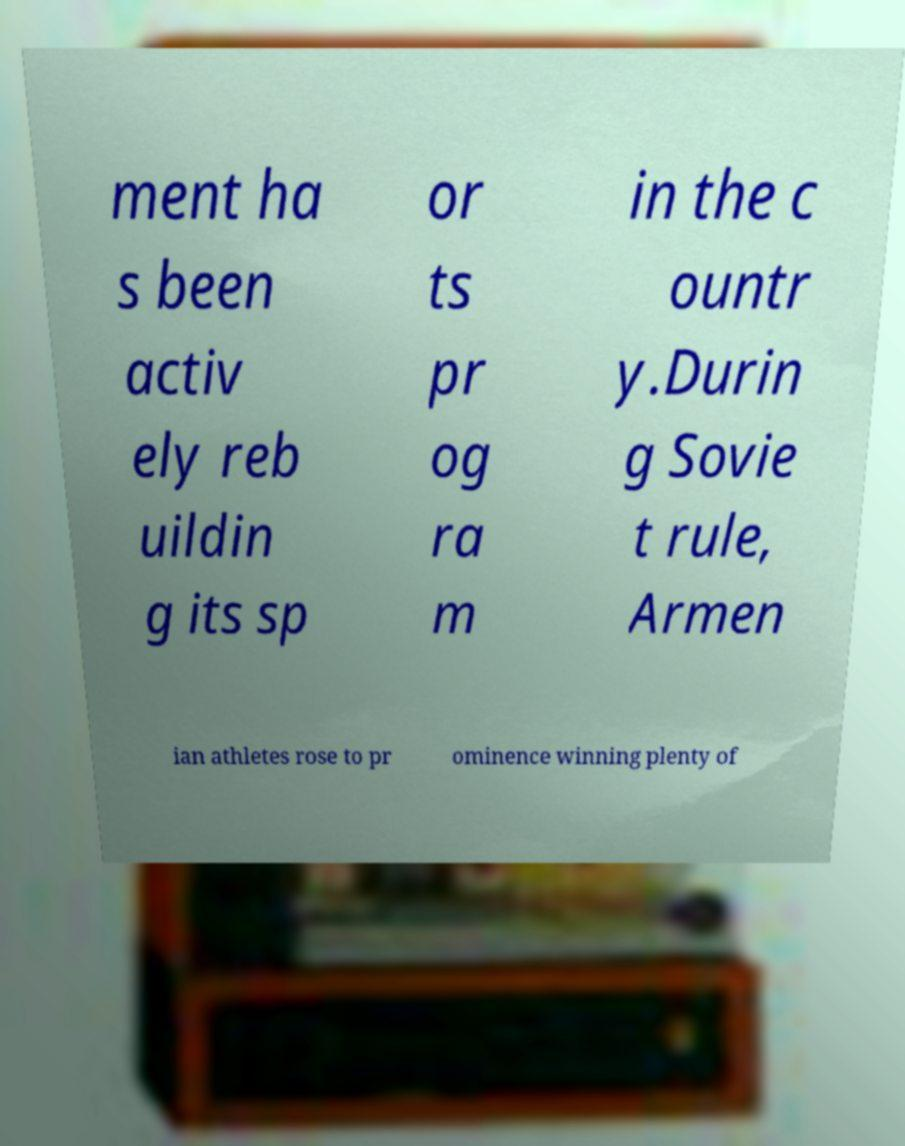What messages or text are displayed in this image? I need them in a readable, typed format. ment ha s been activ ely reb uildin g its sp or ts pr og ra m in the c ountr y.Durin g Sovie t rule, Armen ian athletes rose to pr ominence winning plenty of 